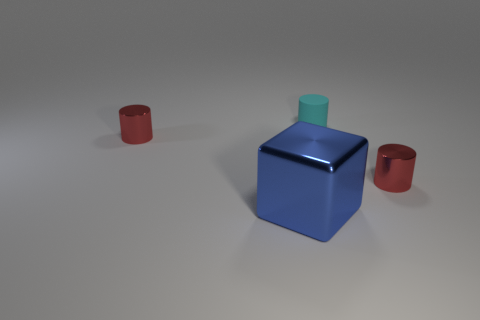Is there any other thing that has the same material as the small cyan cylinder?
Keep it short and to the point. No. Does the small thing that is left of the blue object have the same color as the cylinder that is on the right side of the tiny cyan matte thing?
Keep it short and to the point. Yes. What material is the small red cylinder that is behind the tiny red metallic cylinder in front of the red shiny cylinder to the left of the large blue thing made of?
Offer a terse response. Metal. Are there more cyan matte cylinders than big green cylinders?
Your answer should be very brief. Yes. Is there any other thing that is the same color as the small rubber thing?
Offer a terse response. No. What is the cyan thing made of?
Give a very brief answer. Rubber. How many rubber objects are the same size as the cyan rubber cylinder?
Your answer should be compact. 0. Is there another object of the same shape as the cyan thing?
Keep it short and to the point. Yes. The cylinder that is behind the metallic thing that is to the left of the large shiny cube is what color?
Give a very brief answer. Cyan. What is the shape of the metal object that is in front of the small red object that is in front of the red object that is to the left of the big object?
Provide a succinct answer. Cube. 